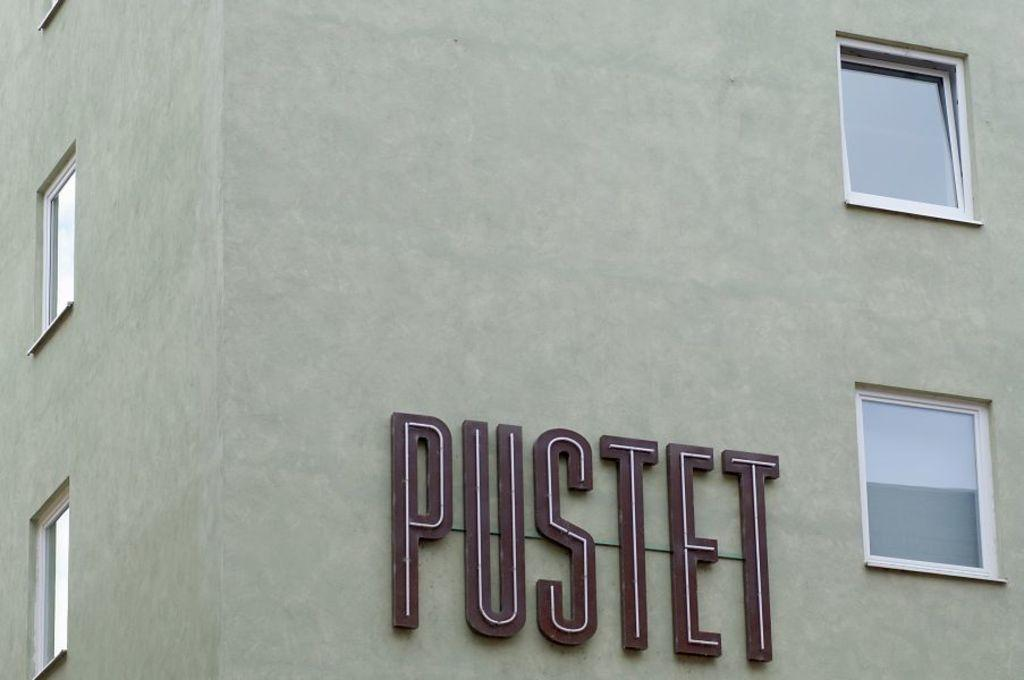What is the main structure in the image? There is a building in the image. What feature can be seen on the building? The building has windows. Is there any text present on the building? Yes, there is text visible on the building. How many clams can be seen crawling on the land in the image? There are no clams present in the image; it features a building with windows and text. 